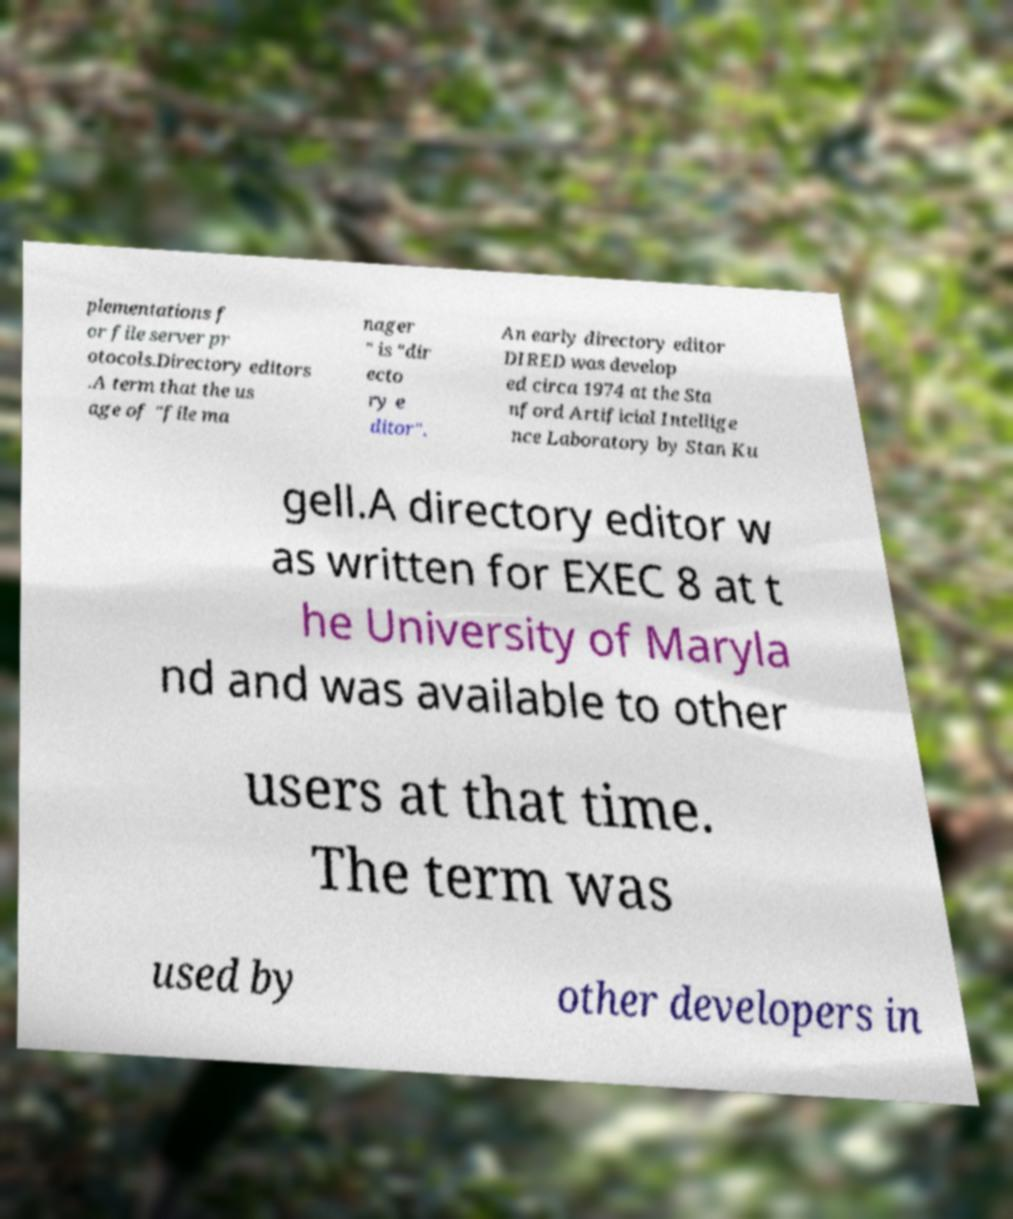Please read and relay the text visible in this image. What does it say? plementations f or file server pr otocols.Directory editors .A term that the us age of "file ma nager " is "dir ecto ry e ditor". An early directory editor DIRED was develop ed circa 1974 at the Sta nford Artificial Intellige nce Laboratory by Stan Ku gell.A directory editor w as written for EXEC 8 at t he University of Maryla nd and was available to other users at that time. The term was used by other developers in 